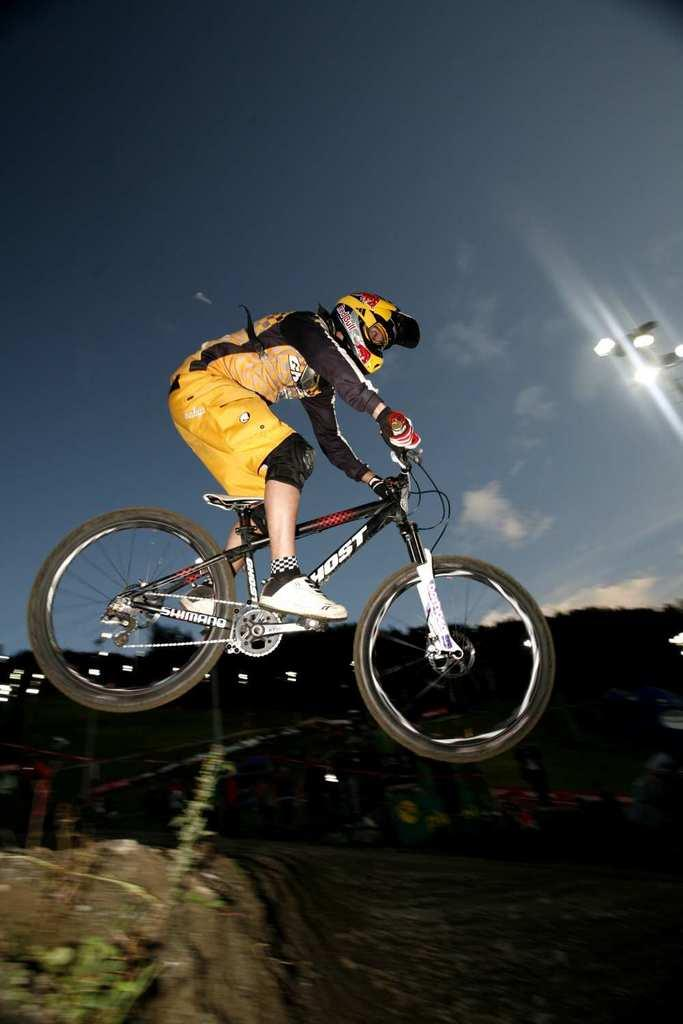What is the man in the image doing? The man is performing stunts. What is the man wearing in the image? The man is wearing a yellow jacket and shorts. What mode of transportation is the man using in the image? The man is riding a black bicycle. What can be seen in the background of the image? There is a street pole and the sky visible in the background of the image. What type of mitten is the man wearing in the image? The man is not wearing any mittens in the image; he is wearing a yellow jacket and shorts. How does the crook in the image affect the man's stunts? There is no crook present in the image; the man is performing stunts on a black bicycle. 